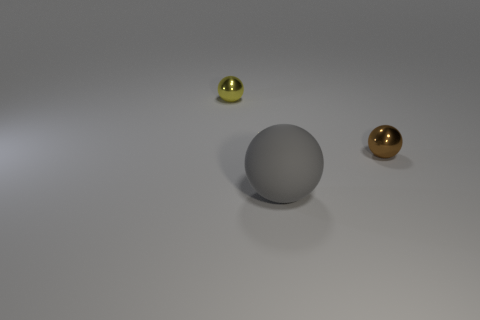Is there anything else that has the same size as the gray ball?
Give a very brief answer. No. Are there any other things that are made of the same material as the large gray ball?
Make the answer very short. No. What number of small things are gray rubber balls or cyan metallic objects?
Make the answer very short. 0. What material is the thing behind the small shiny object that is to the right of the small yellow object?
Make the answer very short. Metal. Is there a brown ball made of the same material as the gray thing?
Offer a very short reply. No. Is the tiny brown thing made of the same material as the gray thing that is in front of the small yellow thing?
Ensure brevity in your answer.  No. The other metallic ball that is the same size as the yellow metallic ball is what color?
Your response must be concise. Brown. There is a shiny thing that is to the right of the shiny ball that is behind the small brown shiny sphere; how big is it?
Your response must be concise. Small. Does the big object have the same color as the tiny sphere that is on the right side of the yellow metallic sphere?
Provide a succinct answer. No. Are there fewer brown shiny things that are left of the brown metal sphere than large metal objects?
Your answer should be compact. No. 